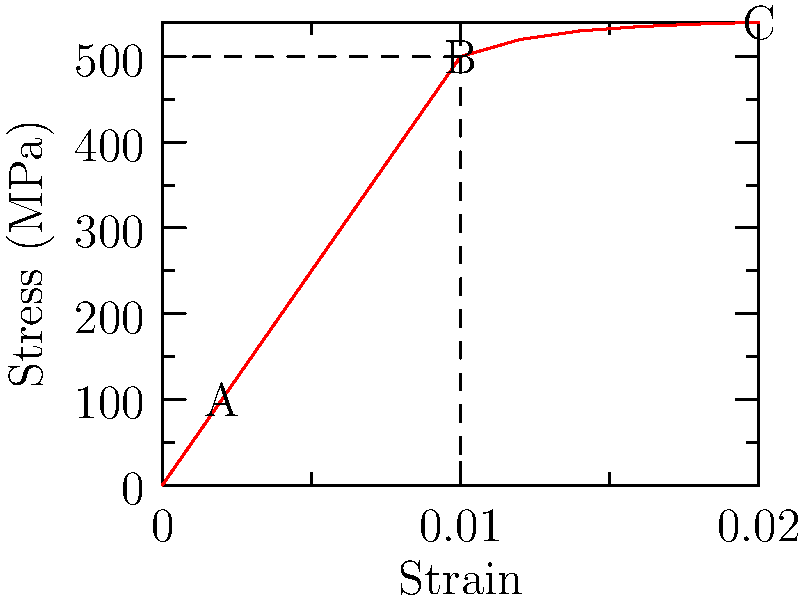Given the stress-strain curve for a material undergoing elastic and plastic deformation, determine the elastic modulus (Young's modulus) of the material in GPa. Assume the linear portion of the curve extends from the origin to point A. To calculate the elastic modulus (Young's modulus), we need to follow these steps:

1) Identify the linear elastic region: This is the straight line from the origin to point A.

2) Calculate the slope of this line using the formula:
   $E = \frac{\Delta \sigma}{\Delta \epsilon}$
   where $E$ is Young's modulus, $\Delta \sigma$ is the change in stress, and $\Delta \epsilon$ is the change in strain.

3) From the graph:
   $\Delta \sigma = 100$ MPa (y-coordinate of point A)
   $\Delta \epsilon = 0.002$ (x-coordinate of point A)

4) Substitute these values into the formula:
   $E = \frac{100 \text{ MPa}}{0.002}$

5) Simplify:
   $E = 50,000$ MPa

6) Convert MPa to GPa:
   $E = 50,000 \text{ MPa} \times \frac{1 \text{ GPa}}{1000 \text{ MPa}} = 50$ GPa

Therefore, the elastic modulus (Young's modulus) of the material is 50 GPa.
Answer: 50 GPa 